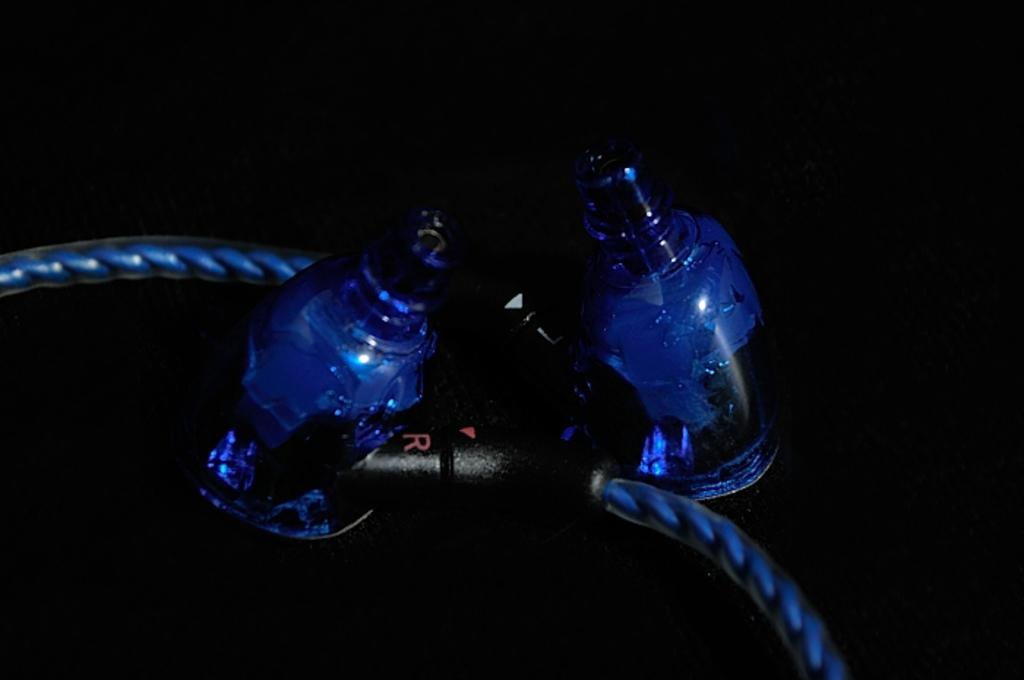<image>
Relay a brief, clear account of the picture shown. A black piece of plastic has an R and L on each side/ 